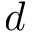<formula> <loc_0><loc_0><loc_500><loc_500>d</formula> 